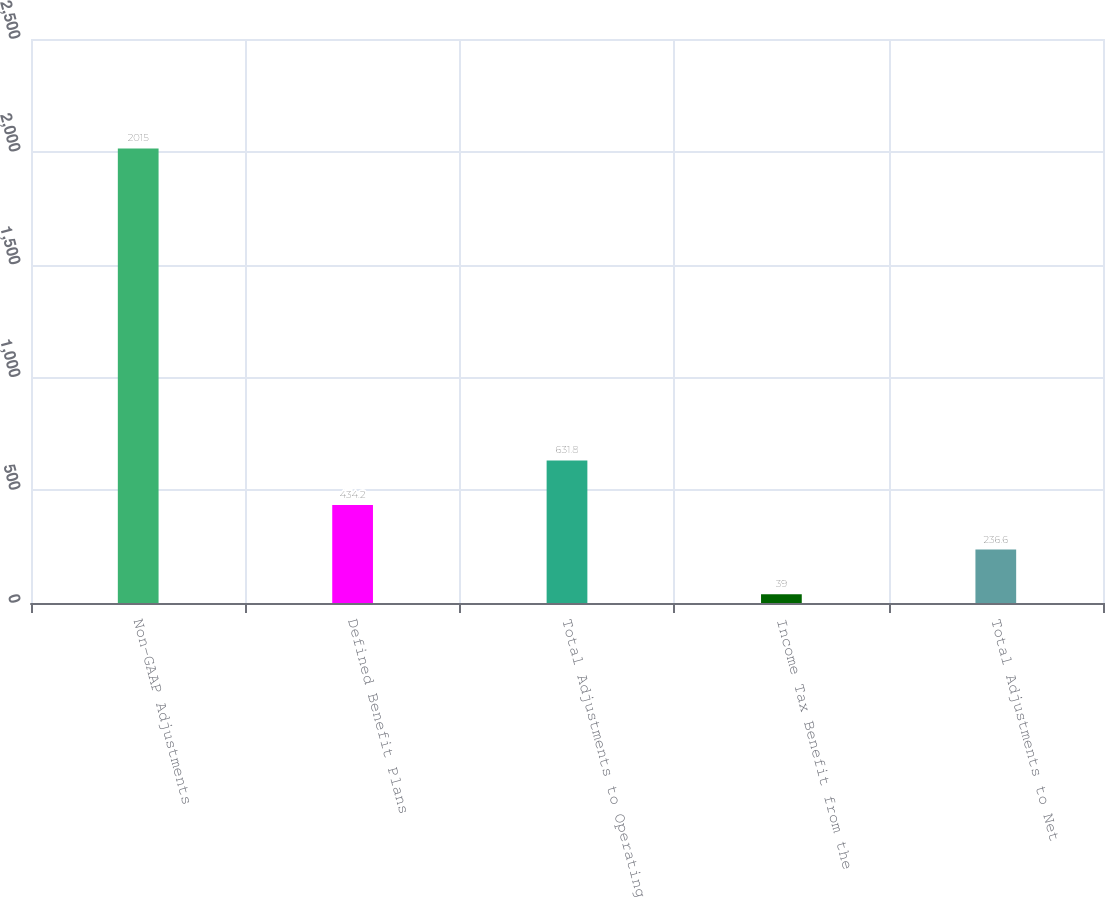Convert chart to OTSL. <chart><loc_0><loc_0><loc_500><loc_500><bar_chart><fcel>Non-GAAP Adjustments<fcel>Defined Benefit Plans<fcel>Total Adjustments to Operating<fcel>Income Tax Benefit from the<fcel>Total Adjustments to Net<nl><fcel>2015<fcel>434.2<fcel>631.8<fcel>39<fcel>236.6<nl></chart> 